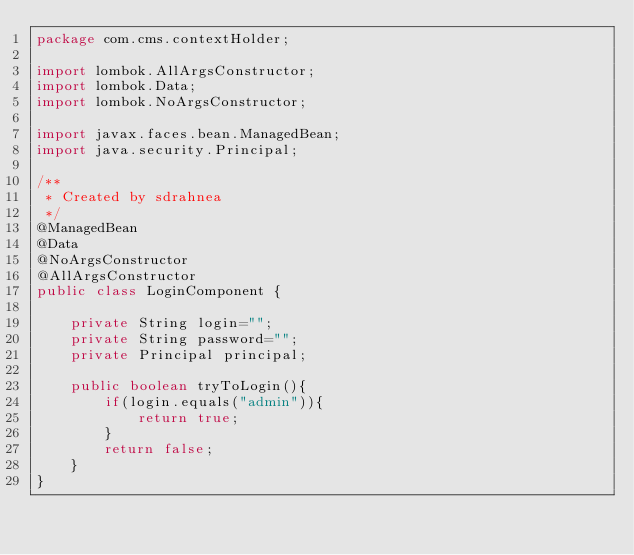<code> <loc_0><loc_0><loc_500><loc_500><_Java_>package com.cms.contextHolder;

import lombok.AllArgsConstructor;
import lombok.Data;
import lombok.NoArgsConstructor;

import javax.faces.bean.ManagedBean;
import java.security.Principal;

/**
 * Created by sdrahnea
 */
@ManagedBean
@Data
@NoArgsConstructor
@AllArgsConstructor
public class LoginComponent {

    private String login="";
    private String password="";
    private Principal principal;

    public boolean tryToLogin(){
        if(login.equals("admin")){
            return true;
        }
        return false;
    }
}
</code> 